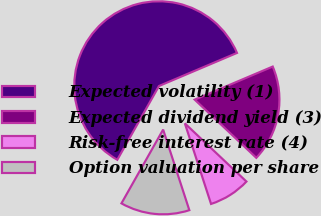Convert chart. <chart><loc_0><loc_0><loc_500><loc_500><pie_chart><fcel>Expected volatility (1)<fcel>Expected dividend yield (3)<fcel>Risk-free interest rate (4)<fcel>Option valuation per share<nl><fcel>60.43%<fcel>18.43%<fcel>7.95%<fcel>13.19%<nl></chart> 